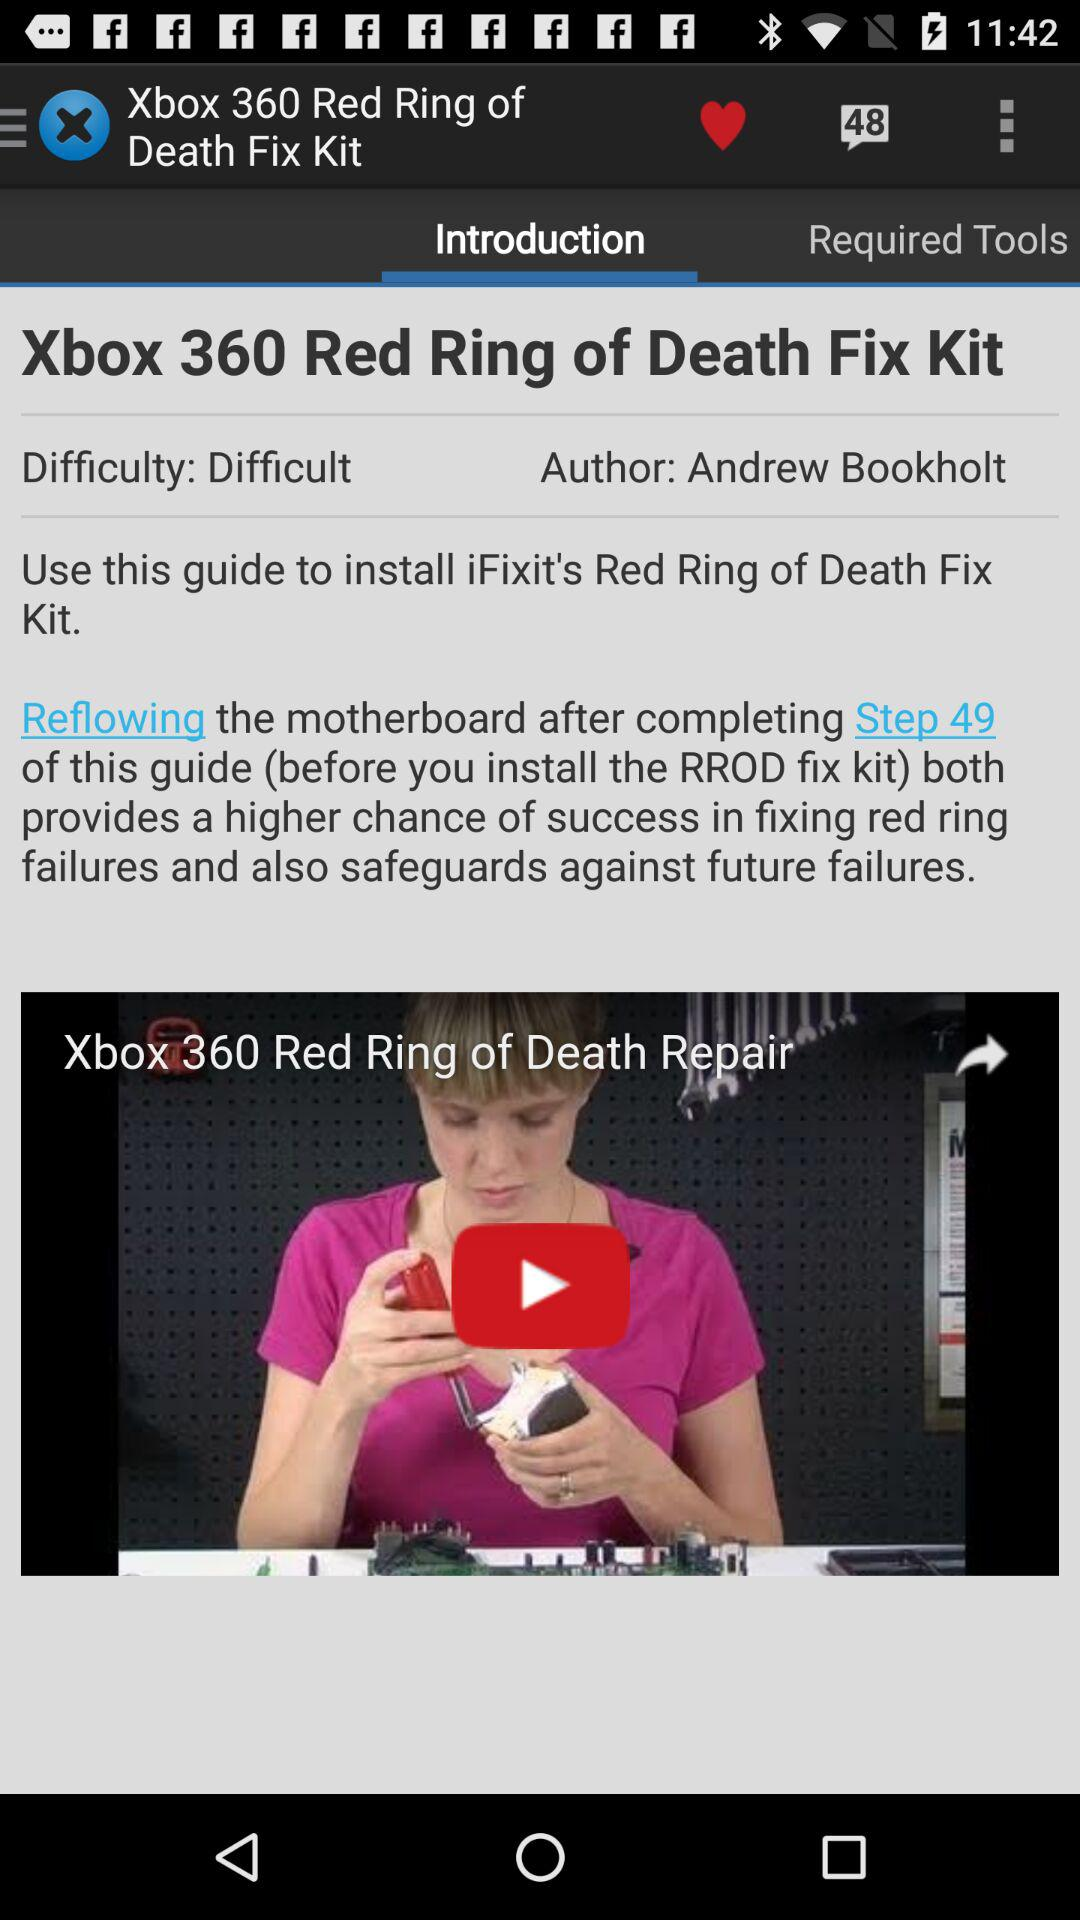What is the number of comments? The number of comments is 48. 